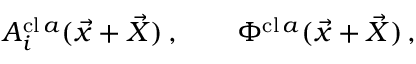Convert formula to latex. <formula><loc_0><loc_0><loc_500><loc_500>A _ { i } ^ { c l \, a } ( \vec { x } + \vec { X } ) \, , \quad \Phi ^ { c l \, a } ( \vec { x } + \vec { X } ) \, ,</formula> 